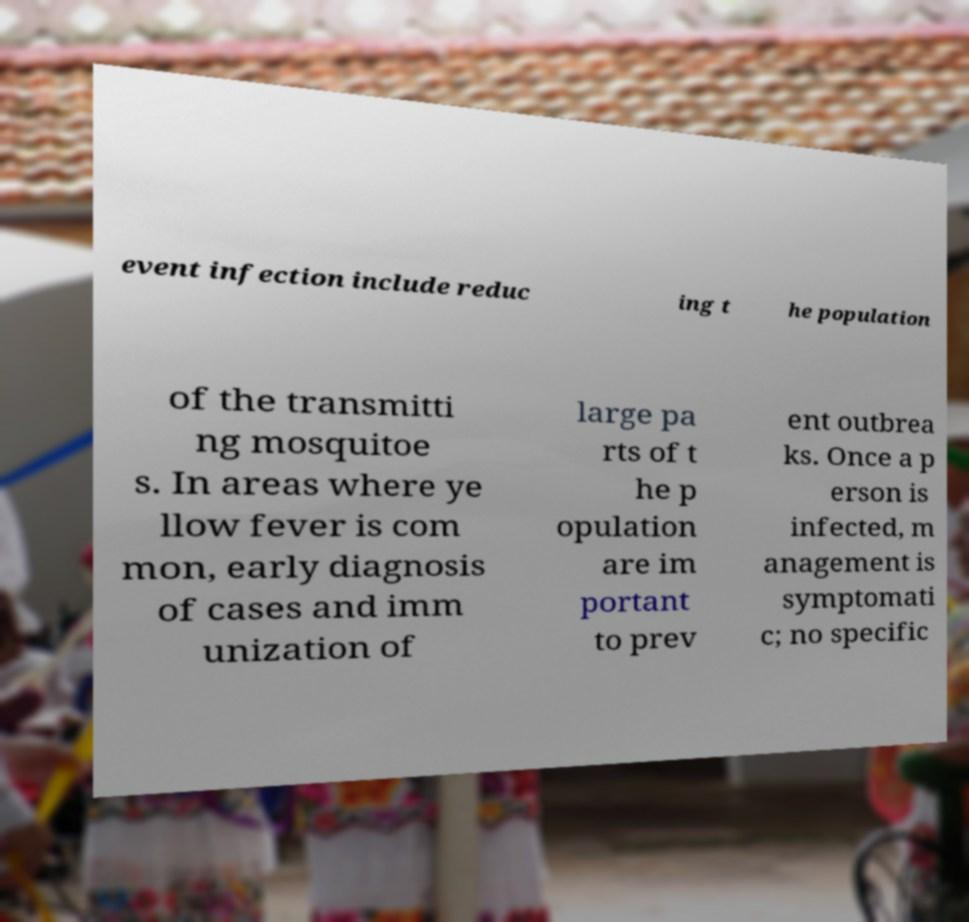There's text embedded in this image that I need extracted. Can you transcribe it verbatim? event infection include reduc ing t he population of the transmitti ng mosquitoe s. In areas where ye llow fever is com mon, early diagnosis of cases and imm unization of large pa rts of t he p opulation are im portant to prev ent outbrea ks. Once a p erson is infected, m anagement is symptomati c; no specific 